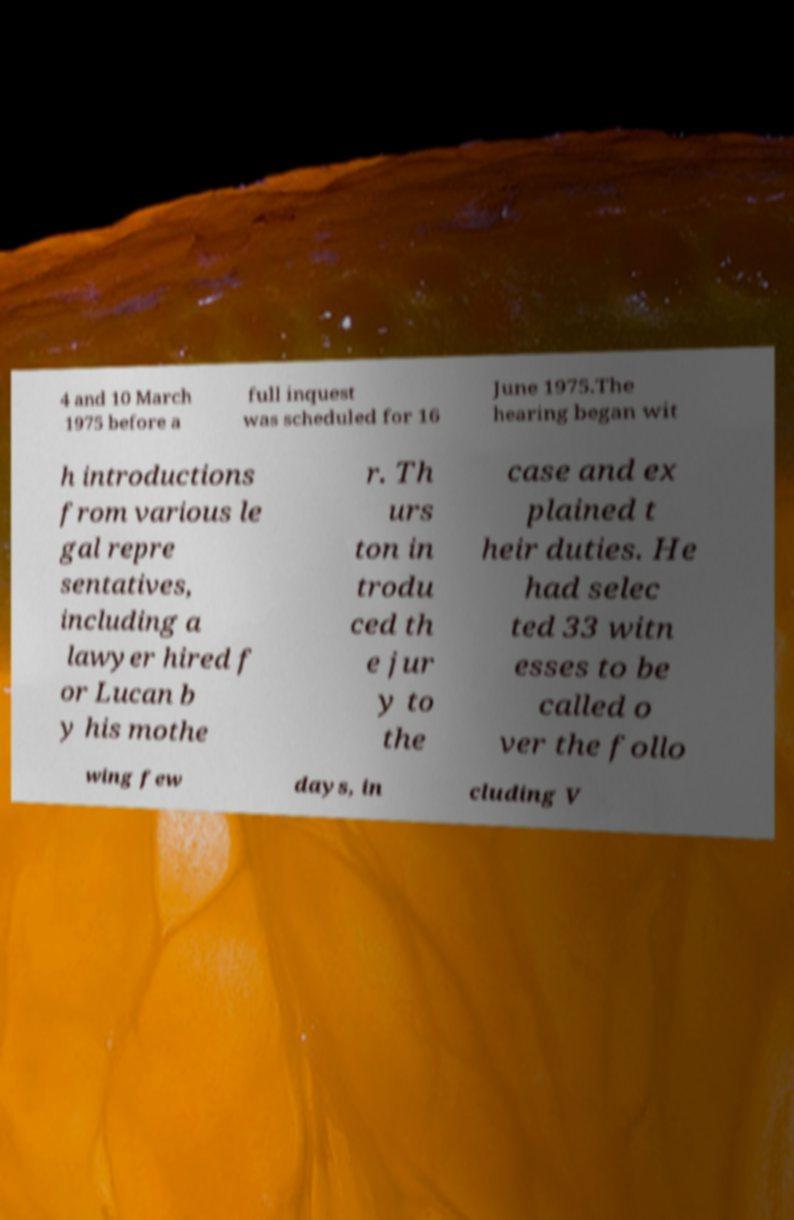Could you assist in decoding the text presented in this image and type it out clearly? 4 and 10 March 1975 before a full inquest was scheduled for 16 June 1975.The hearing began wit h introductions from various le gal repre sentatives, including a lawyer hired f or Lucan b y his mothe r. Th urs ton in trodu ced th e jur y to the case and ex plained t heir duties. He had selec ted 33 witn esses to be called o ver the follo wing few days, in cluding V 